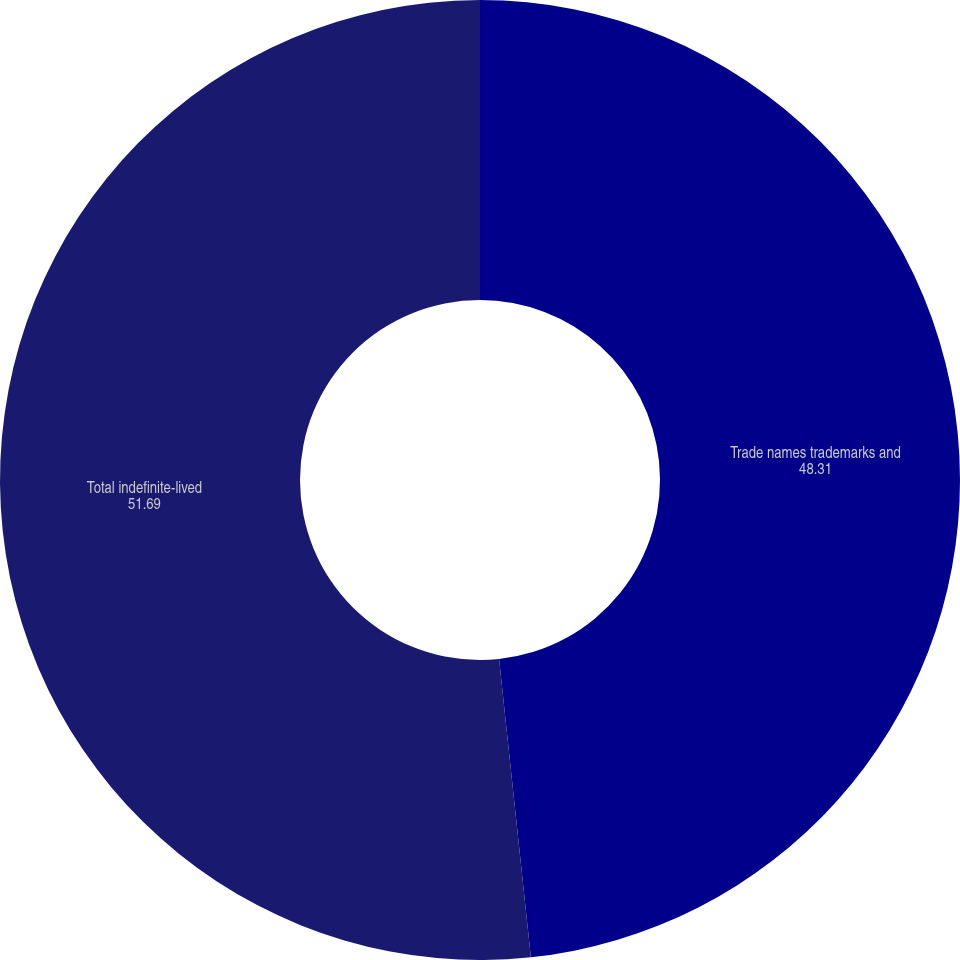Convert chart to OTSL. <chart><loc_0><loc_0><loc_500><loc_500><pie_chart><fcel>Trade names trademarks and<fcel>Total indefinite-lived<nl><fcel>48.31%<fcel>51.69%<nl></chart> 